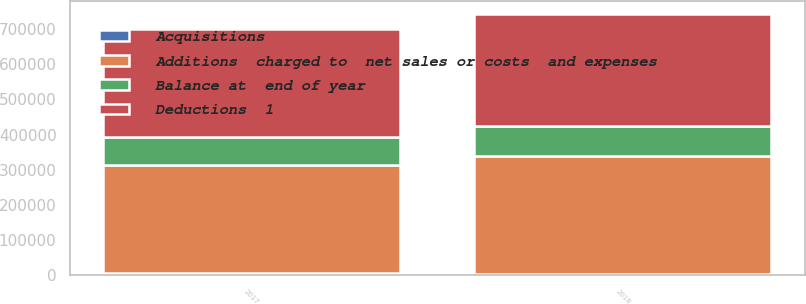Convert chart. <chart><loc_0><loc_0><loc_500><loc_500><stacked_bar_chart><ecel><fcel>2017<fcel>2018<nl><fcel>Balance at  end of year<fcel>78335<fcel>86103<nl><fcel>Acquisitions<fcel>6510<fcel>4240<nl><fcel>Deductions  1<fcel>308507<fcel>317716<nl><fcel>Additions  charged to  net sales or costs  and expenses<fcel>307249<fcel>333341<nl></chart> 